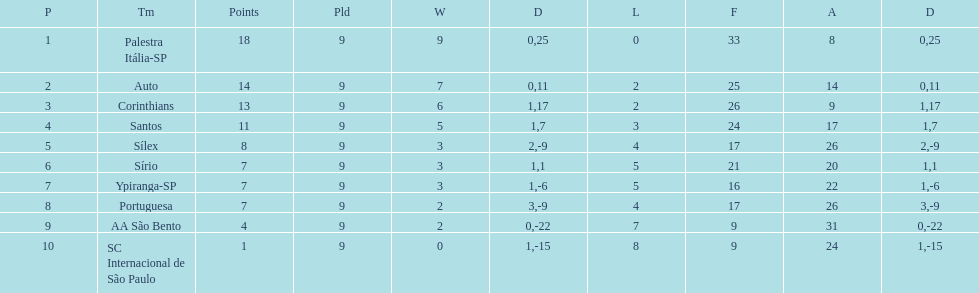How many teams had more points than silex? 4. 